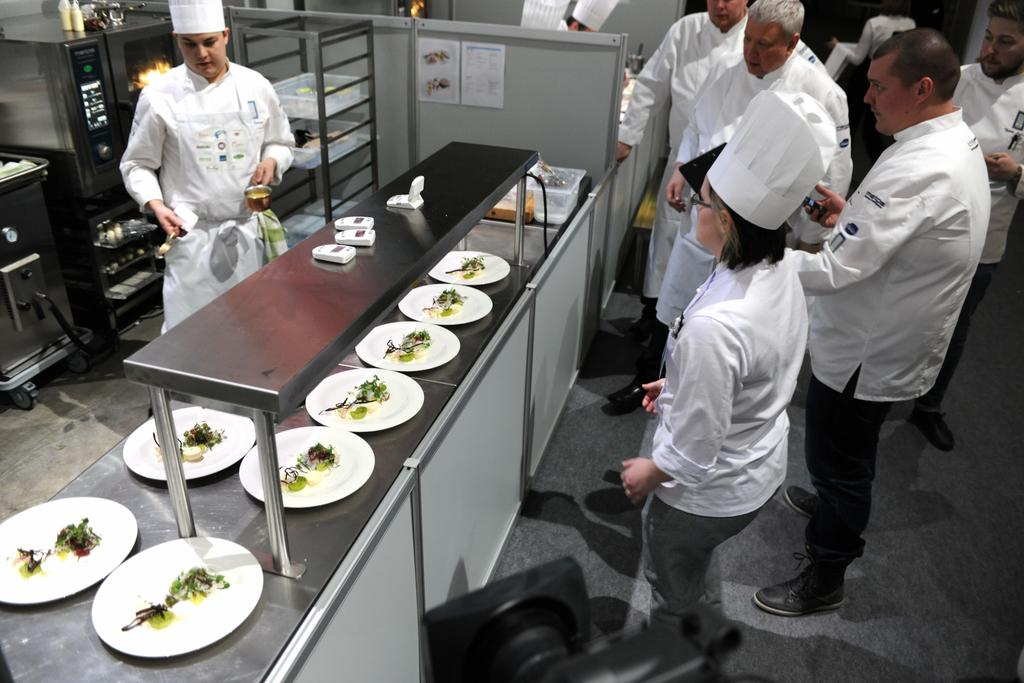How many people are in the image? There is a group of people in the image, but the exact number is not specified. What are the people in the image doing? The people are standing in the image. What can be seen on the plates in the image? There are food items in plates in the image. What type of cooking appliance is present in the image? There is an oven in the image. What other objects can be seen in the image? There are additional objects in the image, but their specific nature is not mentioned. How many frogs are sitting on the box in the image? There is no box or frogs present in the image. 